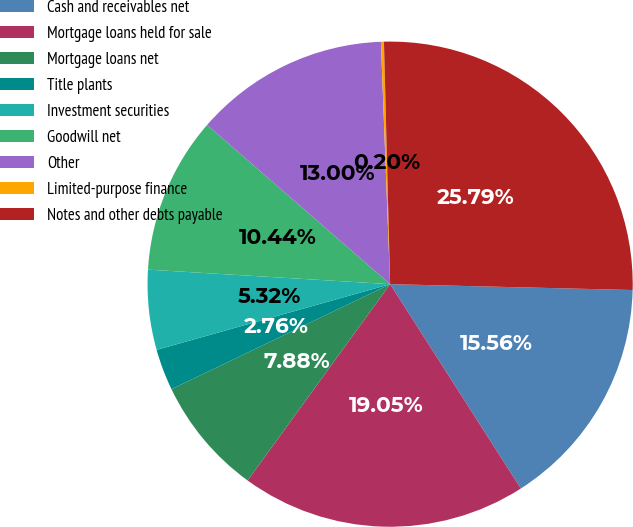<chart> <loc_0><loc_0><loc_500><loc_500><pie_chart><fcel>Cash and receivables net<fcel>Mortgage loans held for sale<fcel>Mortgage loans net<fcel>Title plants<fcel>Investment securities<fcel>Goodwill net<fcel>Other<fcel>Limited-purpose finance<fcel>Notes and other debts payable<nl><fcel>15.56%<fcel>19.05%<fcel>7.88%<fcel>2.76%<fcel>5.32%<fcel>10.44%<fcel>13.0%<fcel>0.2%<fcel>25.79%<nl></chart> 